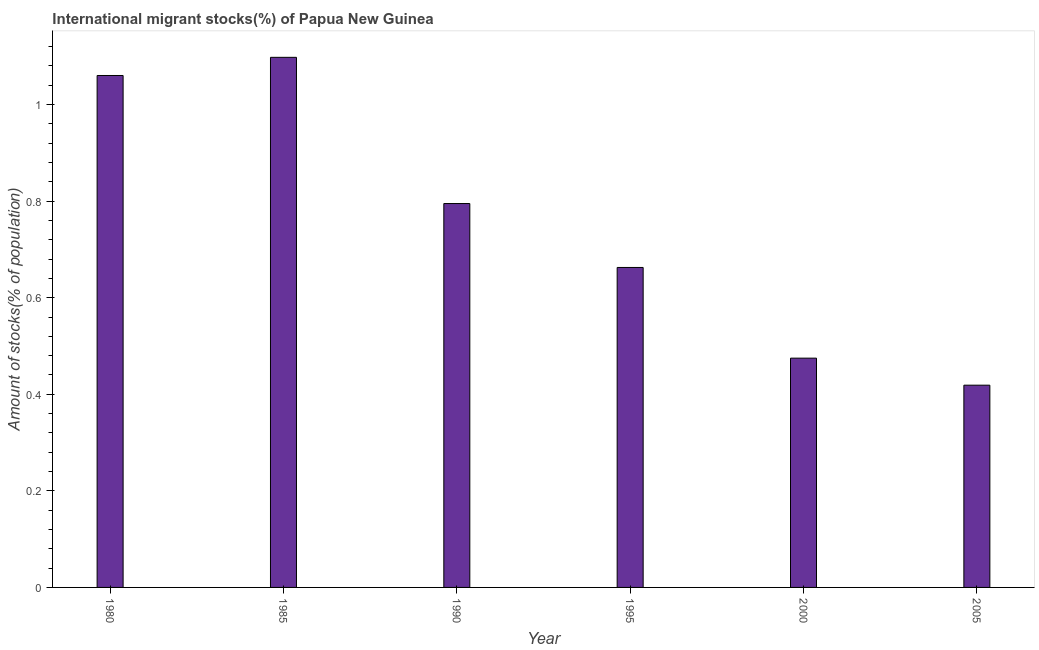Does the graph contain any zero values?
Offer a very short reply. No. Does the graph contain grids?
Give a very brief answer. No. What is the title of the graph?
Your answer should be compact. International migrant stocks(%) of Papua New Guinea. What is the label or title of the X-axis?
Keep it short and to the point. Year. What is the label or title of the Y-axis?
Provide a short and direct response. Amount of stocks(% of population). What is the number of international migrant stocks in 1990?
Your answer should be compact. 0.79. Across all years, what is the maximum number of international migrant stocks?
Offer a very short reply. 1.1. Across all years, what is the minimum number of international migrant stocks?
Ensure brevity in your answer.  0.42. In which year was the number of international migrant stocks minimum?
Your response must be concise. 2005. What is the sum of the number of international migrant stocks?
Keep it short and to the point. 4.51. What is the difference between the number of international migrant stocks in 1990 and 2005?
Provide a short and direct response. 0.38. What is the average number of international migrant stocks per year?
Your response must be concise. 0.75. What is the median number of international migrant stocks?
Make the answer very short. 0.73. What is the ratio of the number of international migrant stocks in 1980 to that in 1995?
Keep it short and to the point. 1.6. Is the number of international migrant stocks in 1990 less than that in 2005?
Provide a succinct answer. No. What is the difference between the highest and the second highest number of international migrant stocks?
Offer a very short reply. 0.04. What is the difference between the highest and the lowest number of international migrant stocks?
Offer a very short reply. 0.68. In how many years, is the number of international migrant stocks greater than the average number of international migrant stocks taken over all years?
Provide a short and direct response. 3. Are all the bars in the graph horizontal?
Provide a succinct answer. No. What is the Amount of stocks(% of population) in 1980?
Your response must be concise. 1.06. What is the Amount of stocks(% of population) in 1985?
Provide a succinct answer. 1.1. What is the Amount of stocks(% of population) in 1990?
Keep it short and to the point. 0.79. What is the Amount of stocks(% of population) of 1995?
Provide a short and direct response. 0.66. What is the Amount of stocks(% of population) in 2000?
Offer a very short reply. 0.47. What is the Amount of stocks(% of population) of 2005?
Your response must be concise. 0.42. What is the difference between the Amount of stocks(% of population) in 1980 and 1985?
Give a very brief answer. -0.04. What is the difference between the Amount of stocks(% of population) in 1980 and 1990?
Offer a terse response. 0.27. What is the difference between the Amount of stocks(% of population) in 1980 and 1995?
Your answer should be very brief. 0.4. What is the difference between the Amount of stocks(% of population) in 1980 and 2000?
Your response must be concise. 0.59. What is the difference between the Amount of stocks(% of population) in 1980 and 2005?
Make the answer very short. 0.64. What is the difference between the Amount of stocks(% of population) in 1985 and 1990?
Provide a succinct answer. 0.3. What is the difference between the Amount of stocks(% of population) in 1985 and 1995?
Make the answer very short. 0.44. What is the difference between the Amount of stocks(% of population) in 1985 and 2000?
Provide a succinct answer. 0.62. What is the difference between the Amount of stocks(% of population) in 1985 and 2005?
Give a very brief answer. 0.68. What is the difference between the Amount of stocks(% of population) in 1990 and 1995?
Your answer should be very brief. 0.13. What is the difference between the Amount of stocks(% of population) in 1990 and 2000?
Your answer should be compact. 0.32. What is the difference between the Amount of stocks(% of population) in 1990 and 2005?
Offer a terse response. 0.38. What is the difference between the Amount of stocks(% of population) in 1995 and 2000?
Ensure brevity in your answer.  0.19. What is the difference between the Amount of stocks(% of population) in 1995 and 2005?
Your answer should be very brief. 0.24. What is the difference between the Amount of stocks(% of population) in 2000 and 2005?
Ensure brevity in your answer.  0.06. What is the ratio of the Amount of stocks(% of population) in 1980 to that in 1985?
Offer a very short reply. 0.97. What is the ratio of the Amount of stocks(% of population) in 1980 to that in 1990?
Keep it short and to the point. 1.33. What is the ratio of the Amount of stocks(% of population) in 1980 to that in 1995?
Give a very brief answer. 1.6. What is the ratio of the Amount of stocks(% of population) in 1980 to that in 2000?
Offer a terse response. 2.23. What is the ratio of the Amount of stocks(% of population) in 1980 to that in 2005?
Provide a succinct answer. 2.53. What is the ratio of the Amount of stocks(% of population) in 1985 to that in 1990?
Give a very brief answer. 1.38. What is the ratio of the Amount of stocks(% of population) in 1985 to that in 1995?
Offer a very short reply. 1.66. What is the ratio of the Amount of stocks(% of population) in 1985 to that in 2000?
Provide a succinct answer. 2.31. What is the ratio of the Amount of stocks(% of population) in 1985 to that in 2005?
Make the answer very short. 2.62. What is the ratio of the Amount of stocks(% of population) in 1990 to that in 1995?
Keep it short and to the point. 1.2. What is the ratio of the Amount of stocks(% of population) in 1990 to that in 2000?
Keep it short and to the point. 1.67. What is the ratio of the Amount of stocks(% of population) in 1990 to that in 2005?
Your answer should be compact. 1.9. What is the ratio of the Amount of stocks(% of population) in 1995 to that in 2000?
Give a very brief answer. 1.4. What is the ratio of the Amount of stocks(% of population) in 1995 to that in 2005?
Provide a short and direct response. 1.58. What is the ratio of the Amount of stocks(% of population) in 2000 to that in 2005?
Offer a terse response. 1.13. 